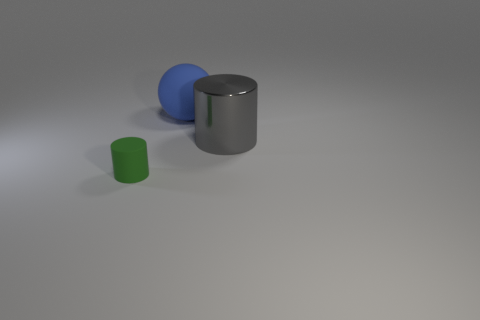Add 2 blue metallic cylinders. How many objects exist? 5 Subtract all cylinders. How many objects are left? 1 Subtract 0 brown cylinders. How many objects are left? 3 Subtract all big green metallic cylinders. Subtract all gray metallic cylinders. How many objects are left? 2 Add 1 balls. How many balls are left? 2 Add 3 small yellow metallic cylinders. How many small yellow metallic cylinders exist? 3 